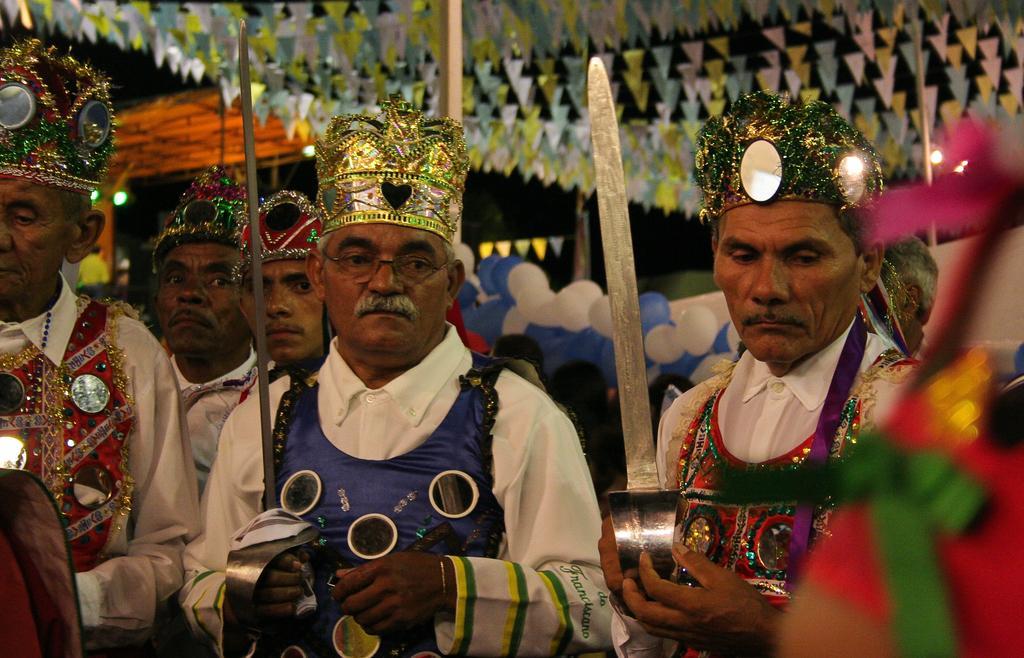In one or two sentences, can you explain what this image depicts? In this picture, we see the men are standing. They are wearing the costumes. Two of them are holding the swords in their hands. Behind them, we see the people. Behind them, we see the balloons in white and blue color. At the top, we see the roof and the flags in white, green, yellow, blue and pink color. In the background, it is black in color. 